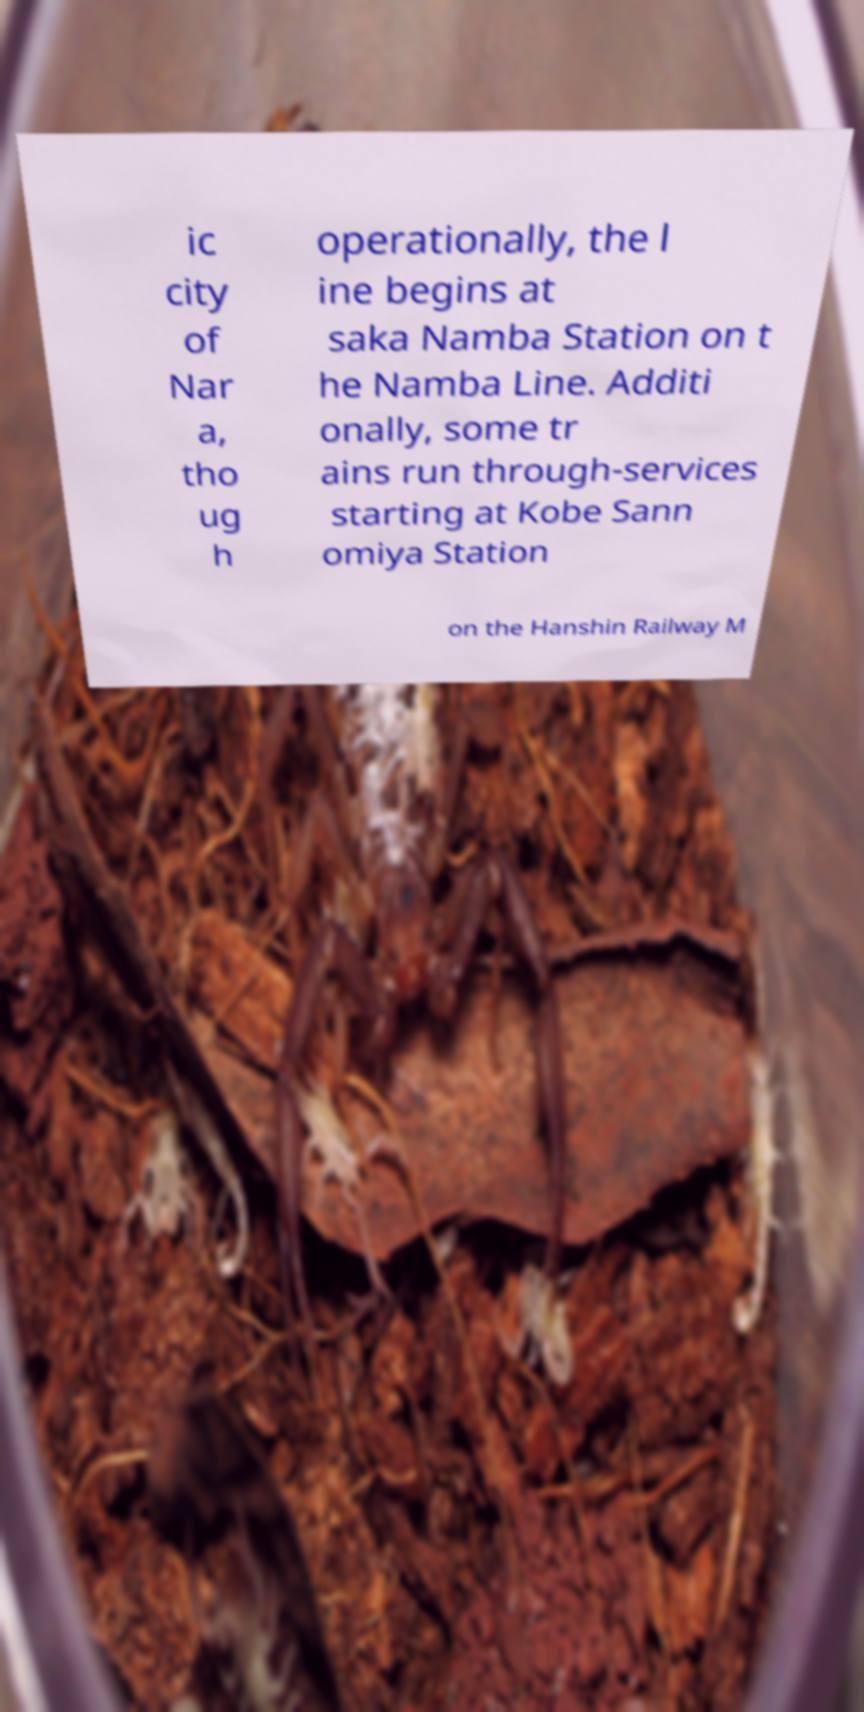Can you read and provide the text displayed in the image?This photo seems to have some interesting text. Can you extract and type it out for me? ic city of Nar a, tho ug h operationally, the l ine begins at saka Namba Station on t he Namba Line. Additi onally, some tr ains run through-services starting at Kobe Sann omiya Station on the Hanshin Railway M 